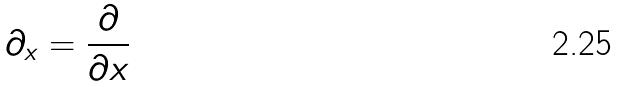Convert formula to latex. <formula><loc_0><loc_0><loc_500><loc_500>\partial _ { x } = \frac { \partial } { \partial x }</formula> 